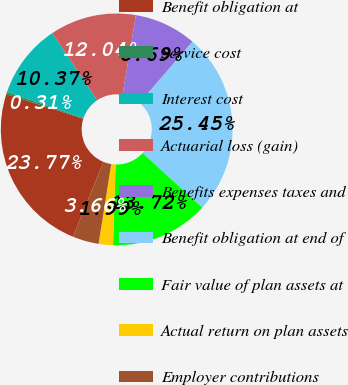Convert chart. <chart><loc_0><loc_0><loc_500><loc_500><pie_chart><fcel>Benefit obligation at<fcel>Service cost<fcel>Interest cost<fcel>Actuarial loss (gain)<fcel>Benefits expenses taxes and<fcel>Benefit obligation at end of<fcel>Fair value of plan assets at<fcel>Actual return on plan assets<fcel>Employer contributions<nl><fcel>23.77%<fcel>0.31%<fcel>10.37%<fcel>12.04%<fcel>8.69%<fcel>25.45%<fcel>13.72%<fcel>1.99%<fcel>3.66%<nl></chart> 